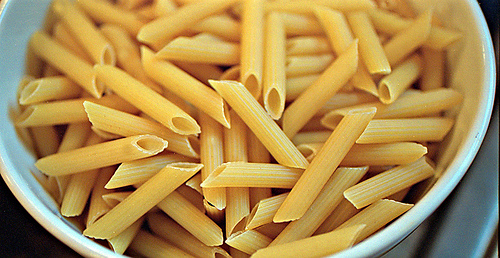<image>
Can you confirm if the pasta is on the bowl? Yes. Looking at the image, I can see the pasta is positioned on top of the bowl, with the bowl providing support. Is the pasta behind the bowl? No. The pasta is not behind the bowl. From this viewpoint, the pasta appears to be positioned elsewhere in the scene. 